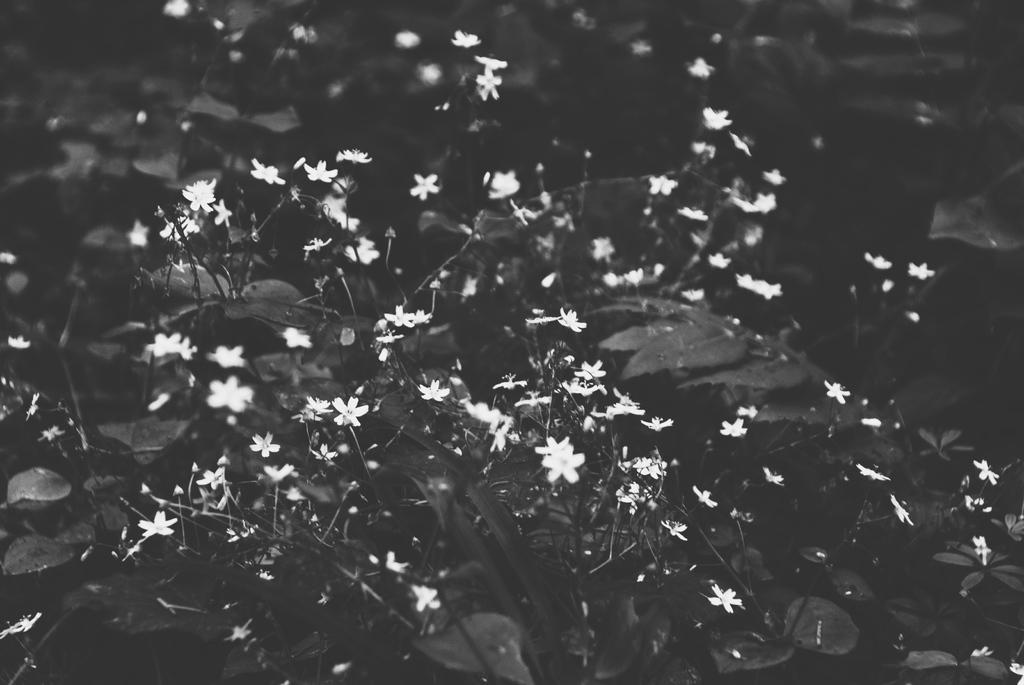What is the color scheme of the image? The image is black and white. What type of vegetation can be seen in the image? There are plants in the image. What specific type of plant is present in the image? There are flowers in the image. Where is the desk located in the image? There is no desk present in the image. What type of crook can be seen in the image? There is no crook present in the image. 